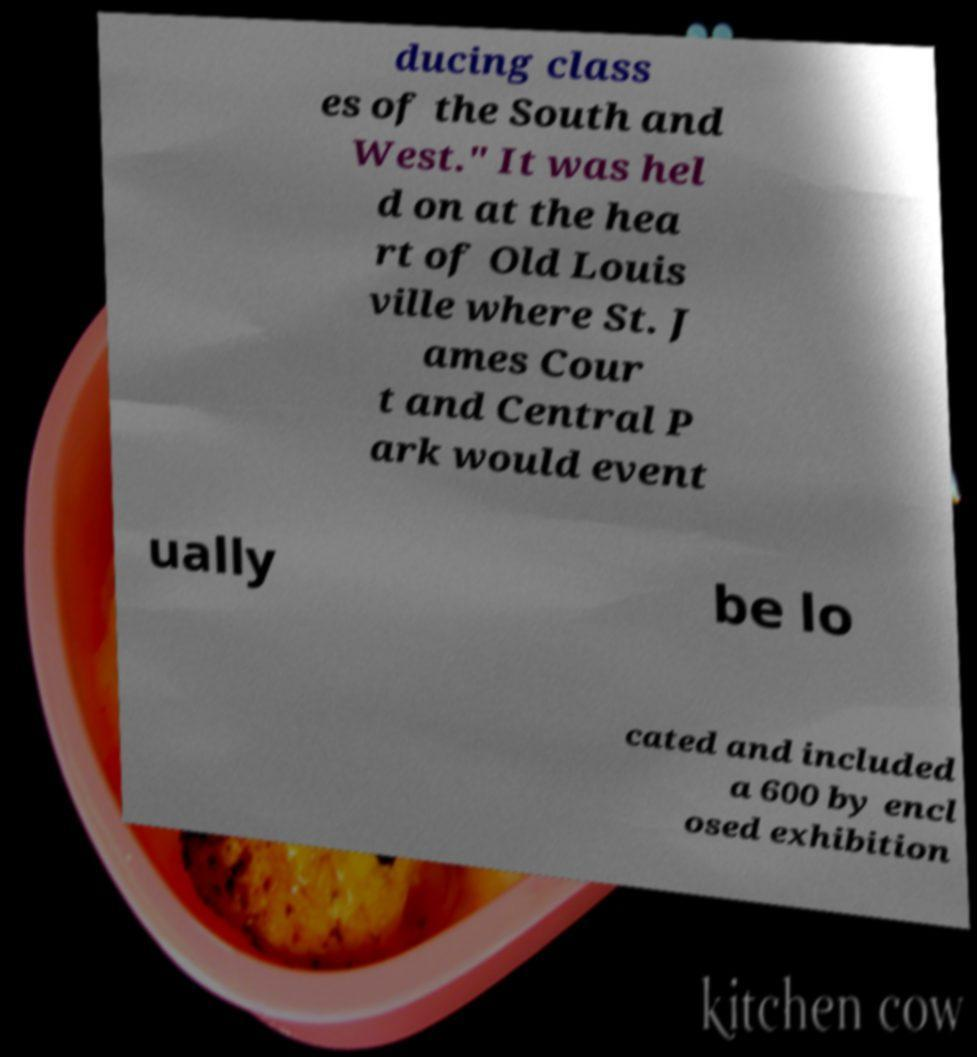I need the written content from this picture converted into text. Can you do that? ducing class es of the South and West." It was hel d on at the hea rt of Old Louis ville where St. J ames Cour t and Central P ark would event ually be lo cated and included a 600 by encl osed exhibition 